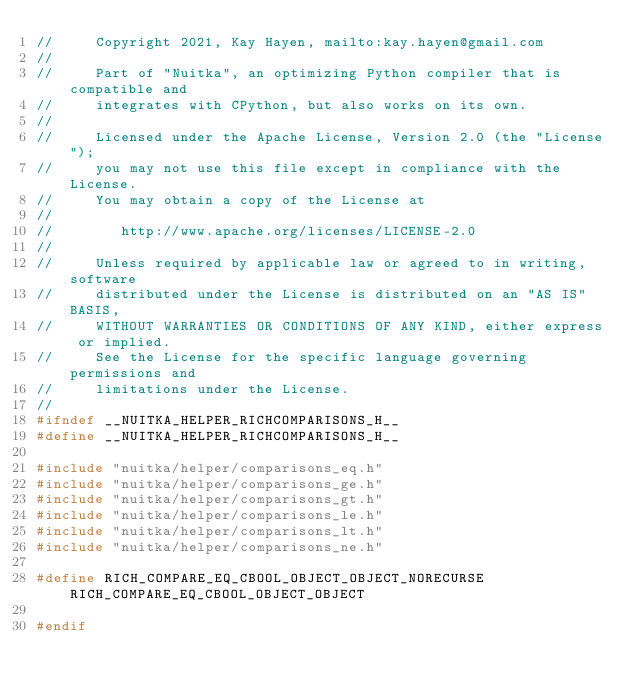Convert code to text. <code><loc_0><loc_0><loc_500><loc_500><_C_>//     Copyright 2021, Kay Hayen, mailto:kay.hayen@gmail.com
//
//     Part of "Nuitka", an optimizing Python compiler that is compatible and
//     integrates with CPython, but also works on its own.
//
//     Licensed under the Apache License, Version 2.0 (the "License");
//     you may not use this file except in compliance with the License.
//     You may obtain a copy of the License at
//
//        http://www.apache.org/licenses/LICENSE-2.0
//
//     Unless required by applicable law or agreed to in writing, software
//     distributed under the License is distributed on an "AS IS" BASIS,
//     WITHOUT WARRANTIES OR CONDITIONS OF ANY KIND, either express or implied.
//     See the License for the specific language governing permissions and
//     limitations under the License.
//
#ifndef __NUITKA_HELPER_RICHCOMPARISONS_H__
#define __NUITKA_HELPER_RICHCOMPARISONS_H__

#include "nuitka/helper/comparisons_eq.h"
#include "nuitka/helper/comparisons_ge.h"
#include "nuitka/helper/comparisons_gt.h"
#include "nuitka/helper/comparisons_le.h"
#include "nuitka/helper/comparisons_lt.h"
#include "nuitka/helper/comparisons_ne.h"

#define RICH_COMPARE_EQ_CBOOL_OBJECT_OBJECT_NORECURSE RICH_COMPARE_EQ_CBOOL_OBJECT_OBJECT

#endif
</code> 